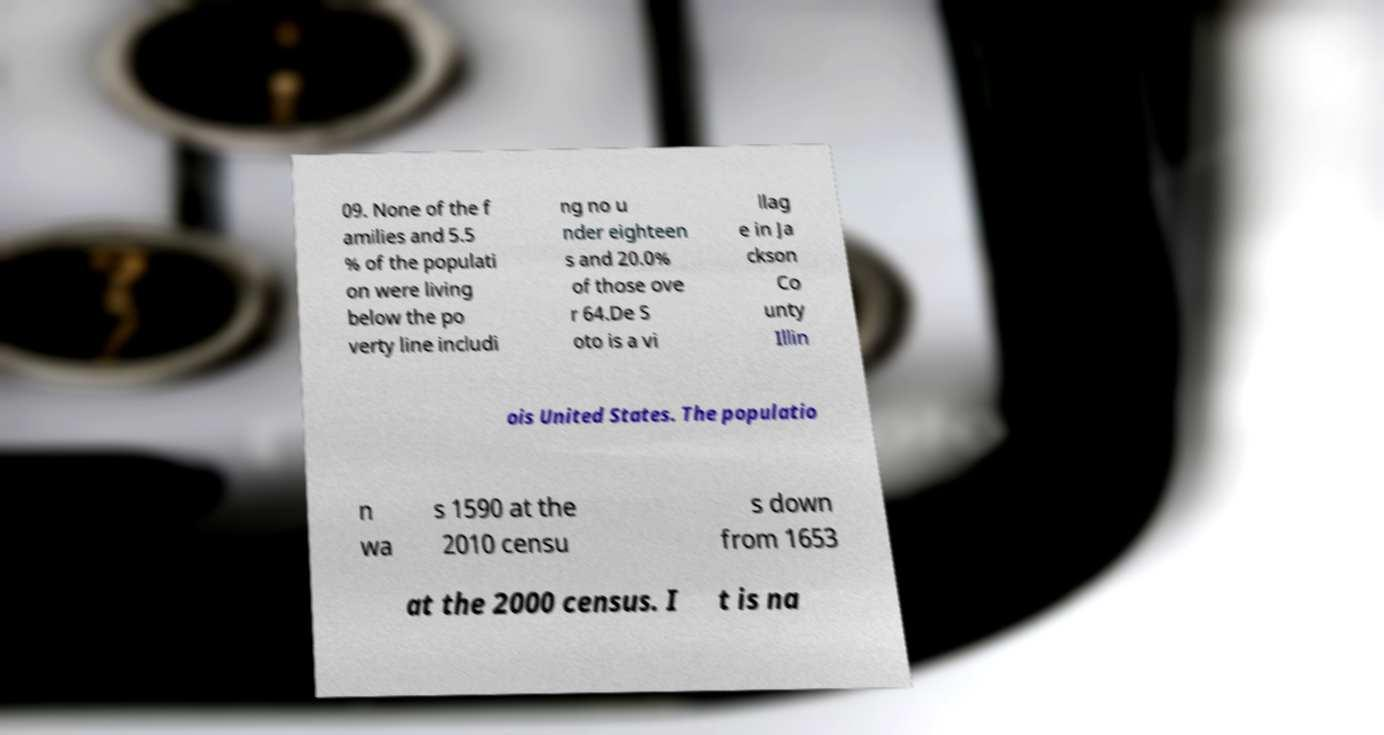There's text embedded in this image that I need extracted. Can you transcribe it verbatim? 09. None of the f amilies and 5.5 % of the populati on were living below the po verty line includi ng no u nder eighteen s and 20.0% of those ove r 64.De S oto is a vi llag e in Ja ckson Co unty Illin ois United States. The populatio n wa s 1590 at the 2010 censu s down from 1653 at the 2000 census. I t is na 